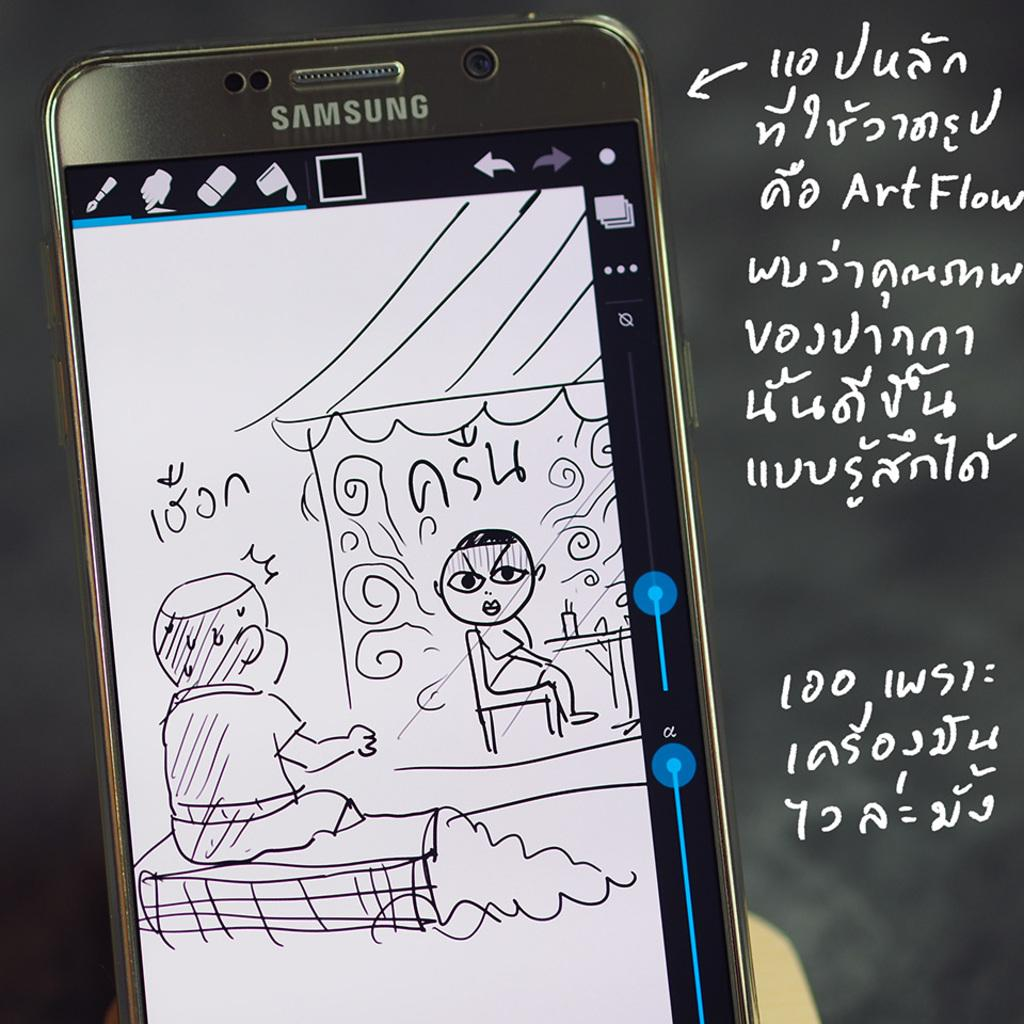<image>
Relay a brief, clear account of the picture shown. a drawing of a boy that says 100n on it 